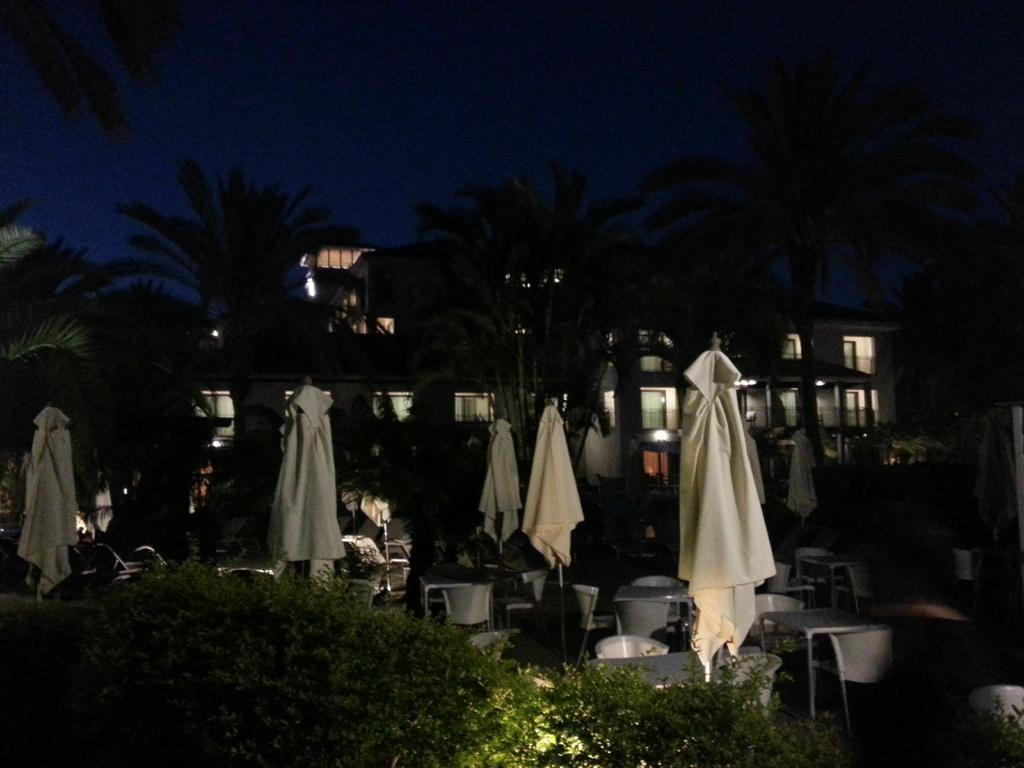What type of living organisms can be seen in the image? Plants and trees are visible in the image. What objects are present in the image that might be used for protection from the rain? Folded umbrellas are present in the image. What type of furniture can be seen in the image? Tables and chairs are visible in the image. What structures are visible in the image that have lights? There are buildings with lights in the image. What type of natural scenery is visible in the image? Trees are visible in the image. What part of the natural environment is visible in the image? The sky is visible in the image. What statement is written on the chalkboard in the image? There is no chalkboard present in the image, so no statement can be read. What is the name of the person sitting on the chair in the image? There is no person sitting on a chair in the image, so their name cannot be determined. 